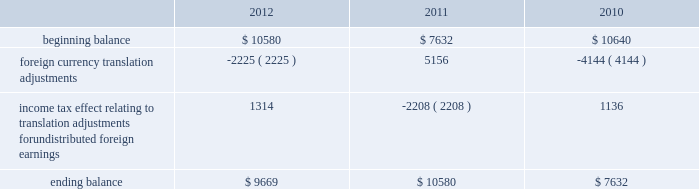The table sets forth the components of foreign currency translation adjustments for fiscal 2012 , 2011 and 2010 ( in thousands ) : .
Stock repurchase program to facilitate our stock repurchase program , designed to return value to our stockholders and minimize dilution from stock issuances , we repurchase shares in the open market and also enter into structured repurchase agreements with third-parties .
Authorization to repurchase shares to cover on-going dilution was not subject to expiration .
However , this repurchase program was limited to covering net dilution from stock issuances and was subject to business conditions and cash flow requirements as determined by our board of directors from time to time .
During the third quarter of fiscal 2010 , our board of directors approved an amendment to our stock repurchase program authorized in april 2007 from a non-expiring share-based authority to a time-constrained dollar-based authority .
As part of this amendment , the board of directors granted authority to repurchase up to $ 1.6 billion in common stock through the end of fiscal 2012 .
During the second quarter of fiscal 2012 , we exhausted our $ 1.6 billion authority granted by our board of directors in fiscal in april 2012 , the board of directors approved a new stock repurchase program granting authority to repurchase up to $ 2.0 billion in common stock through the end of fiscal 2015 .
The new stock repurchase program approved by our board of directors is similar to our previous $ 1.6 billion stock repurchase program .
During fiscal 2012 , 2011 and 2010 , we entered into several structured repurchase agreements with large financial institutions , whereupon we provided the financial institutions with prepayments totaling $ 405.0 million , $ 695.0 million and $ 850 million , respectively .
Of the $ 405.0 million of prepayments during fiscal 2012 , $ 100.0 million was under the new $ 2.0 billion stock repurchase program and the remaining $ 305.0 million was under our previous $ 1.6 billion authority .
Of the $ 850.0 million of prepayments during fiscal 2010 , $ 250.0 million was under the stock repurchase program prior to the program amendment in the third quarter of fiscal 2010 and the remaining $ 600.0 million was under the amended $ 1.6 billion time-constrained dollar-based authority .
We enter into these agreements in order to take advantage of repurchasing shares at a guaranteed discount to the volume weighted average price ( 201cvwap 201d ) of our common stock over a specified period of time .
We only enter into such transactions when the discount that we receive is higher than the foregone return on our cash prepayments to the financial institutions .
There were no explicit commissions or fees on these structured repurchases .
Under the terms of the agreements , there is no requirement for the financial institutions to return any portion of the prepayment to us .
The financial institutions agree to deliver shares to us at monthly intervals during the contract term .
The parameters used to calculate the number of shares deliverable are : the total notional amount of the contract , the number of trading days in the contract , the number of trading days in the interval and the average vwap of our stock during the interval less the agreed upon discount .
During fiscal 2012 , we repurchased approximately 11.5 million shares at an average price of $ 32.29 through structured repurchase agreements entered into during fiscal 2012 .
During fiscal 2011 , we repurchased approximately 21.8 million shares at an average price of $ 31.81 through structured repurchase agreements entered into during fiscal 2011 .
During fiscal 2010 , we repurchased approximately 31.2 million shares at an average price per share of $ 29.19 through structured repurchase agreements entered into during fiscal 2009 and fiscal 2010 .
For fiscal 2012 , 2011 and 2010 , the prepayments were classified as treasury stock on our consolidated balance sheets at the payment date , though only shares physically delivered to us by november 30 , 2012 , december 2 , 2011 and december 3 , 2010 were excluded from the computation of earnings per share .
As of november 30 , 2012 , $ 33.0 million of prepayments remained under these agreements .
As of december 2 , 2011 and december 3 , 2010 , no prepayments remained under these agreements .
Table of contents adobe systems incorporated notes to consolidated financial statements ( continued ) .
During the second quarter of fiscal 2012 , what was the change in billions from the april 2012 plan to the new stock repurchase program granting authority to repurchase common stock through the end of fiscal 2015? 
Computations: (2 - 1.6)
Answer: 0.4. The table sets forth the components of foreign currency translation adjustments for fiscal 2012 , 2011 and 2010 ( in thousands ) : .
Stock repurchase program to facilitate our stock repurchase program , designed to return value to our stockholders and minimize dilution from stock issuances , we repurchase shares in the open market and also enter into structured repurchase agreements with third-parties .
Authorization to repurchase shares to cover on-going dilution was not subject to expiration .
However , this repurchase program was limited to covering net dilution from stock issuances and was subject to business conditions and cash flow requirements as determined by our board of directors from time to time .
During the third quarter of fiscal 2010 , our board of directors approved an amendment to our stock repurchase program authorized in april 2007 from a non-expiring share-based authority to a time-constrained dollar-based authority .
As part of this amendment , the board of directors granted authority to repurchase up to $ 1.6 billion in common stock through the end of fiscal 2012 .
During the second quarter of fiscal 2012 , we exhausted our $ 1.6 billion authority granted by our board of directors in fiscal in april 2012 , the board of directors approved a new stock repurchase program granting authority to repurchase up to $ 2.0 billion in common stock through the end of fiscal 2015 .
The new stock repurchase program approved by our board of directors is similar to our previous $ 1.6 billion stock repurchase program .
During fiscal 2012 , 2011 and 2010 , we entered into several structured repurchase agreements with large financial institutions , whereupon we provided the financial institutions with prepayments totaling $ 405.0 million , $ 695.0 million and $ 850 million , respectively .
Of the $ 405.0 million of prepayments during fiscal 2012 , $ 100.0 million was under the new $ 2.0 billion stock repurchase program and the remaining $ 305.0 million was under our previous $ 1.6 billion authority .
Of the $ 850.0 million of prepayments during fiscal 2010 , $ 250.0 million was under the stock repurchase program prior to the program amendment in the third quarter of fiscal 2010 and the remaining $ 600.0 million was under the amended $ 1.6 billion time-constrained dollar-based authority .
We enter into these agreements in order to take advantage of repurchasing shares at a guaranteed discount to the volume weighted average price ( 201cvwap 201d ) of our common stock over a specified period of time .
We only enter into such transactions when the discount that we receive is higher than the foregone return on our cash prepayments to the financial institutions .
There were no explicit commissions or fees on these structured repurchases .
Under the terms of the agreements , there is no requirement for the financial institutions to return any portion of the prepayment to us .
The financial institutions agree to deliver shares to us at monthly intervals during the contract term .
The parameters used to calculate the number of shares deliverable are : the total notional amount of the contract , the number of trading days in the contract , the number of trading days in the interval and the average vwap of our stock during the interval less the agreed upon discount .
During fiscal 2012 , we repurchased approximately 11.5 million shares at an average price of $ 32.29 through structured repurchase agreements entered into during fiscal 2012 .
During fiscal 2011 , we repurchased approximately 21.8 million shares at an average price of $ 31.81 through structured repurchase agreements entered into during fiscal 2011 .
During fiscal 2010 , we repurchased approximately 31.2 million shares at an average price per share of $ 29.19 through structured repurchase agreements entered into during fiscal 2009 and fiscal 2010 .
For fiscal 2012 , 2011 and 2010 , the prepayments were classified as treasury stock on our consolidated balance sheets at the payment date , though only shares physically delivered to us by november 30 , 2012 , december 2 , 2011 and december 3 , 2010 were excluded from the computation of earnings per share .
As of november 30 , 2012 , $ 33.0 million of prepayments remained under these agreements .
As of december 2 , 2011 and december 3 , 2010 , no prepayments remained under these agreements .
Table of contents adobe systems incorporated notes to consolidated financial statements ( continued ) .
What is the growth rate in the average price of repurchased shares from 2011 to 2012? 
Computations: ((32.29 - 31.81) / 31.81)
Answer: 0.01509. 